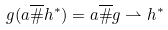Convert formula to latex. <formula><loc_0><loc_0><loc_500><loc_500>g ( a \overline { \# } h ^ { \ast } ) = a \overline { \# } g \rightharpoonup h ^ { \ast }</formula> 